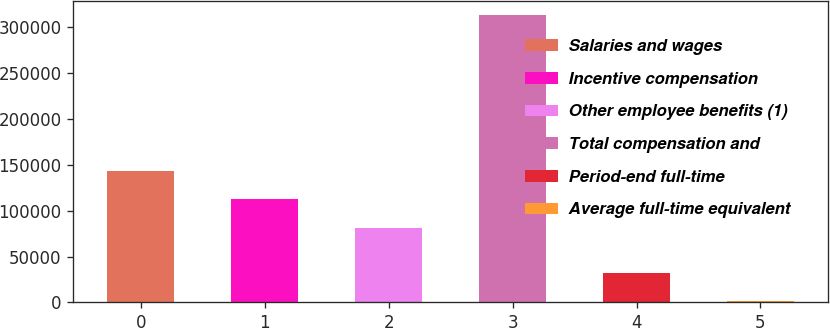<chart> <loc_0><loc_0><loc_500><loc_500><bar_chart><fcel>Salaries and wages<fcel>Incentive compensation<fcel>Other employee benefits (1)<fcel>Total compensation and<fcel>Period-end full-time<fcel>Average full-time equivalent<nl><fcel>143377<fcel>112218<fcel>81059<fcel>313043<fcel>32610.2<fcel>1451<nl></chart> 